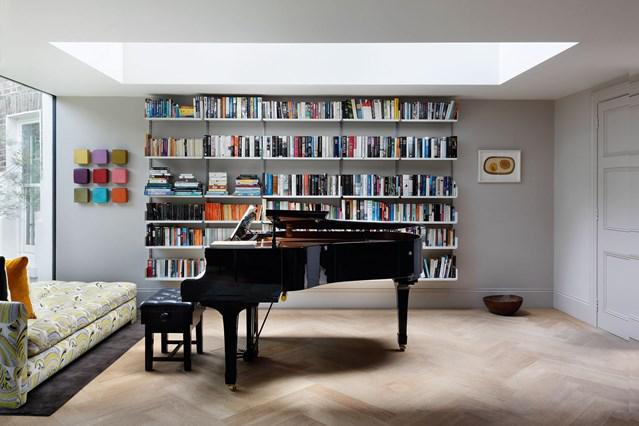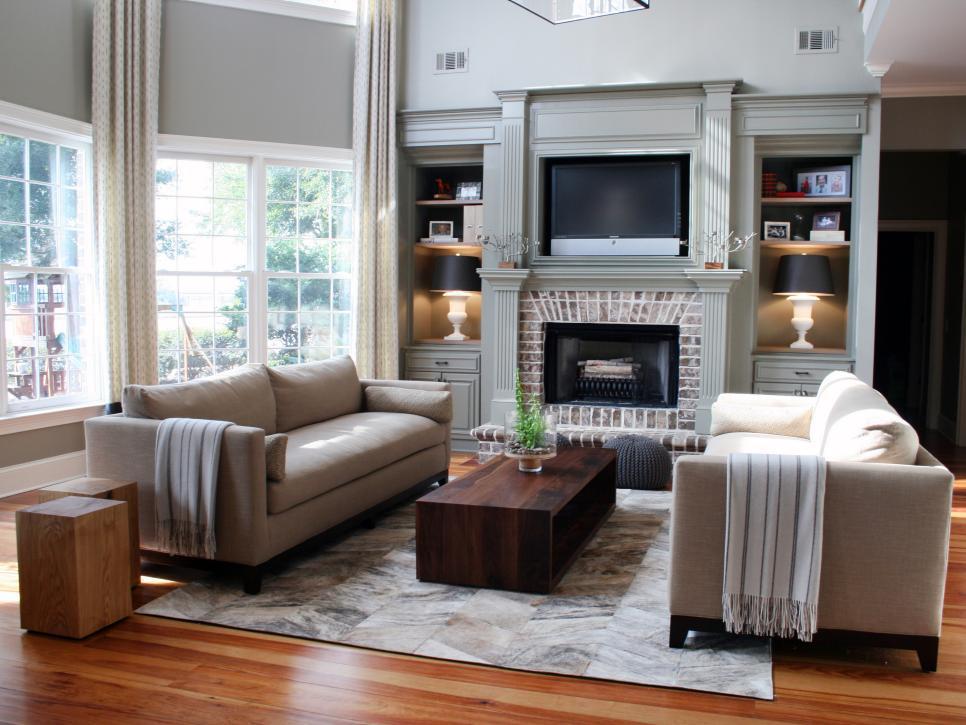The first image is the image on the left, the second image is the image on the right. Given the left and right images, does the statement "A room includes a beige sofa near a fireplace flanked by white built-in bookshelves, with something rectangular over the fireplace." hold true? Answer yes or no. Yes. The first image is the image on the left, the second image is the image on the right. Evaluate the accuracy of this statement regarding the images: "In one image, floor to ceiling bookshelves are on both sides of a central fireplace with decor filling the space above.". Is it true? Answer yes or no. No. 